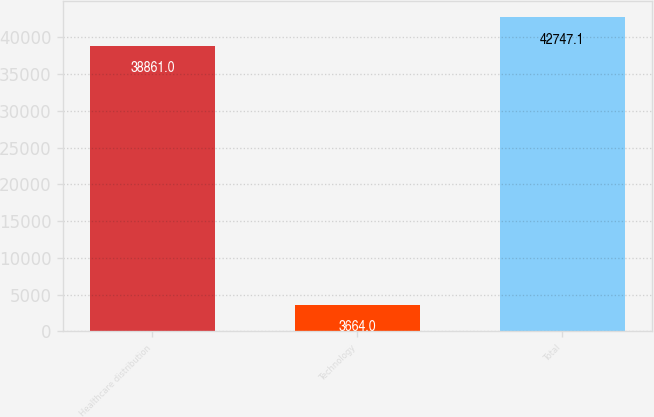Convert chart. <chart><loc_0><loc_0><loc_500><loc_500><bar_chart><fcel>Healthcare distribution<fcel>Technology<fcel>Total<nl><fcel>38861<fcel>3664<fcel>42747.1<nl></chart> 